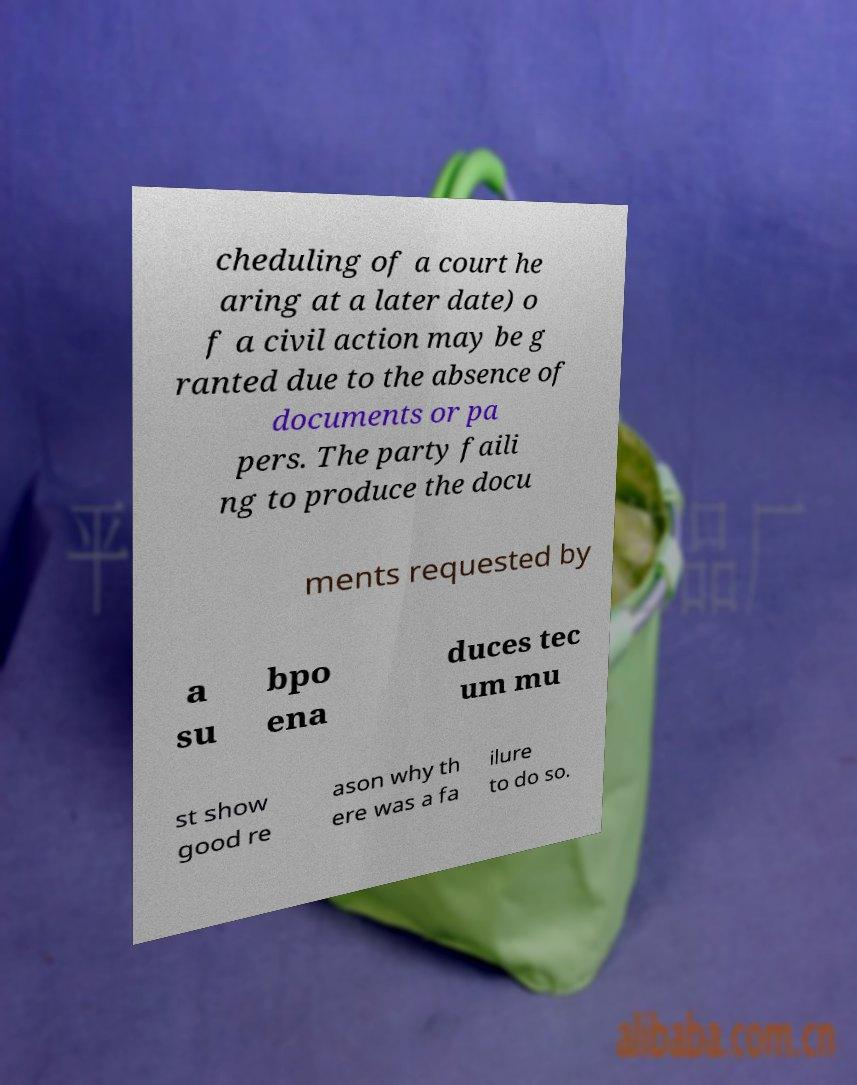Please identify and transcribe the text found in this image. cheduling of a court he aring at a later date) o f a civil action may be g ranted due to the absence of documents or pa pers. The party faili ng to produce the docu ments requested by a su bpo ena duces tec um mu st show good re ason why th ere was a fa ilure to do so. 